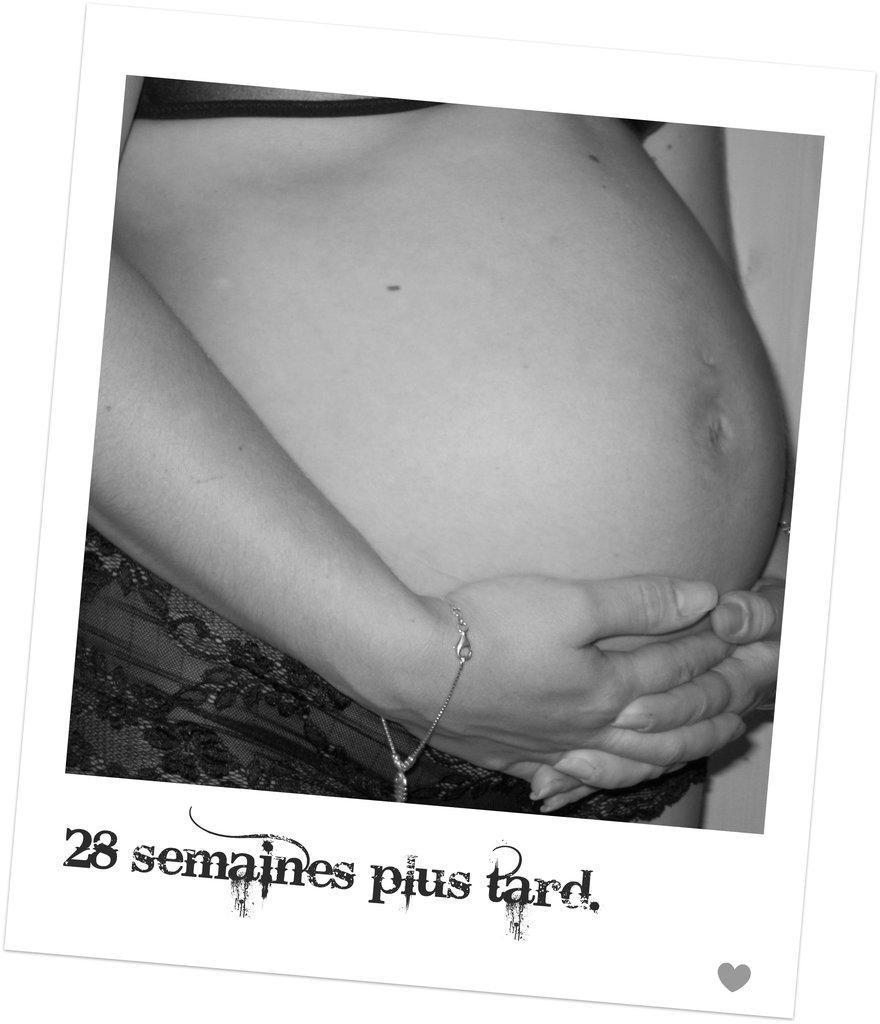What is present in the image? There is a person in the image. What part of the person's body can be seen in the image? The person's stomach and hands are visible in the image. What type of store can be seen in the background of the image? There is no store present in the image; it only features a person with their stomach and hands visible. 